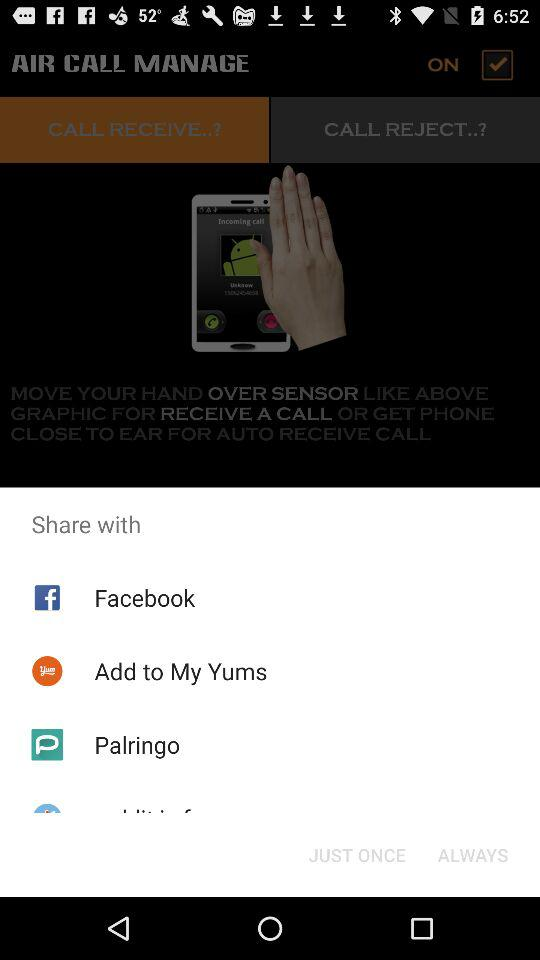What is the status of "AIR CALL MANAGE"? The status of "AIR CALL MANAGE" is "on". 